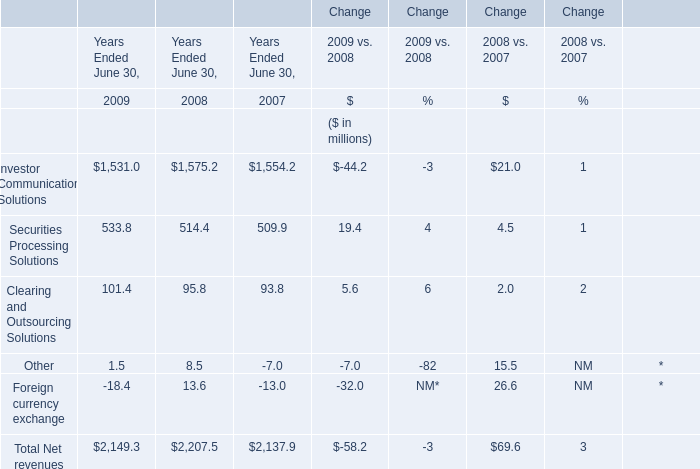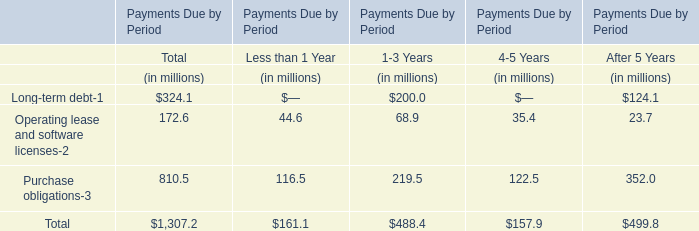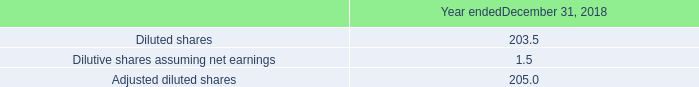What's the difference of Total Net revenues between 2009 and 2008? (in million) 
Computations: (2149.3 - 2207.5)
Answer: -58.2. 